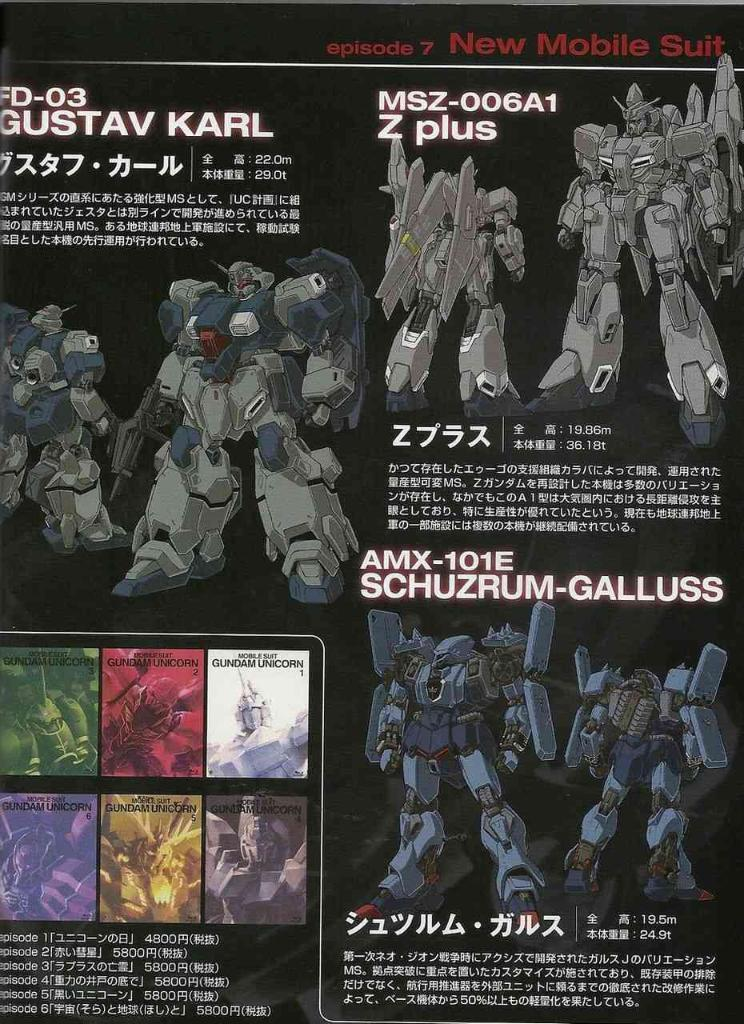<image>
Relay a brief, clear account of the picture shown. A page showing robots seen in episode 7 of New Mobile Suit 